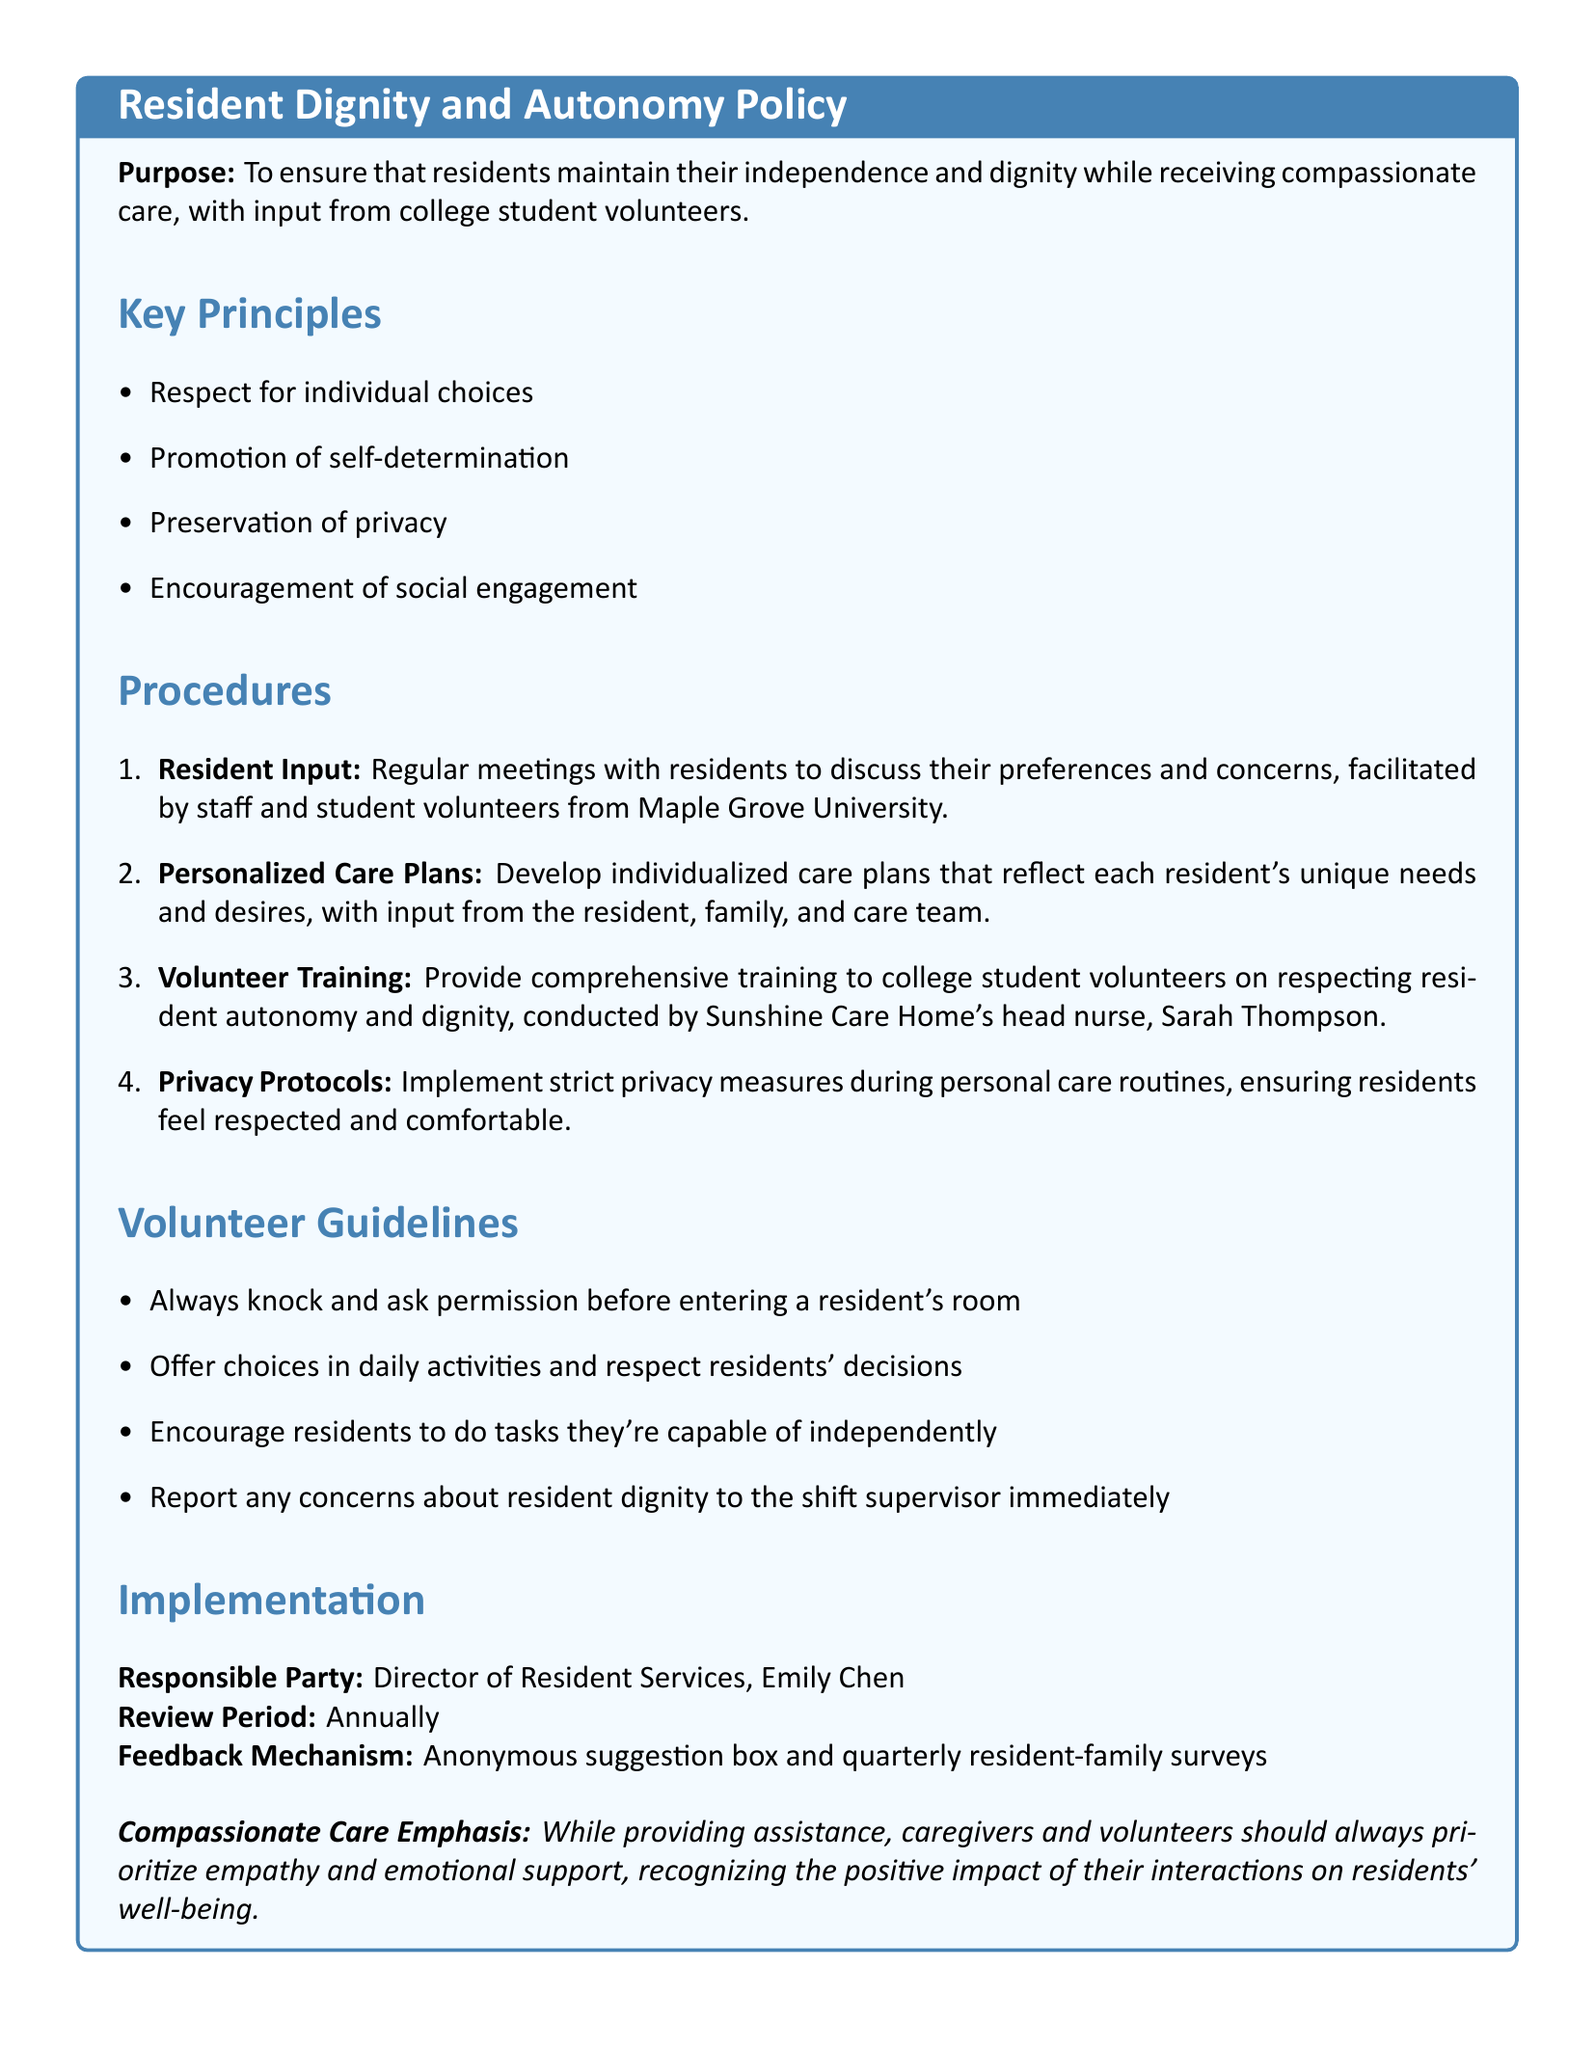what is the purpose of the policy? The purpose section states the aim of the policy, which is to ensure residents maintain their independence and dignity while receiving compassionate care.
Answer: To ensure that residents maintain their independence and dignity while receiving compassionate care, with input from college student volunteers who is responsible for implementing the policy? The implementation section specifies the responsible party for the policy, which is the Director of Resident Services.
Answer: Director of Resident Services, Emily Chen how often will the policy be reviewed? The review period section indicates how frequently the policy will be examined, stated as annually.
Answer: Annually what is the first key principle of the policy? The key principles section outlines several principles, with the first being respect for individual choices.
Answer: Respect for individual choices what training do college student volunteers receive? The procedures section describes the training provided, focusing on respecting resident autonomy and dignity.
Answer: Comprehensive training to college student volunteers on respecting resident autonomy and dignity what mechanism is in place for feedback from residents and families? The implementation section mentions a specific mechanism for collecting feedback, which includes an anonymous suggestion box.
Answer: Anonymous suggestion box and quarterly resident-family surveys 